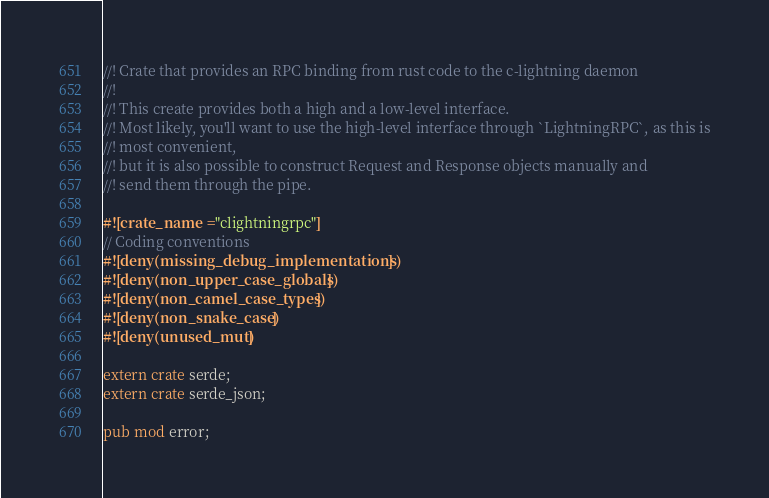Convert code to text. <code><loc_0><loc_0><loc_500><loc_500><_Rust_>
//! Crate that provides an RPC binding from rust code to the c-lightning daemon
//!
//! This create provides both a high and a low-level interface.
//! Most likely, you'll want to use the high-level interface through `LightningRPC`, as this is
//! most convenient,
//! but it is also possible to construct Request and Response objects manually and
//! send them through the pipe.

#![crate_name = "clightningrpc"]
// Coding conventions
#![deny(missing_debug_implementations)]
#![deny(non_upper_case_globals)]
#![deny(non_camel_case_types)]
#![deny(non_snake_case)]
#![deny(unused_mut)]

extern crate serde;
extern crate serde_json;

pub mod error;</code> 